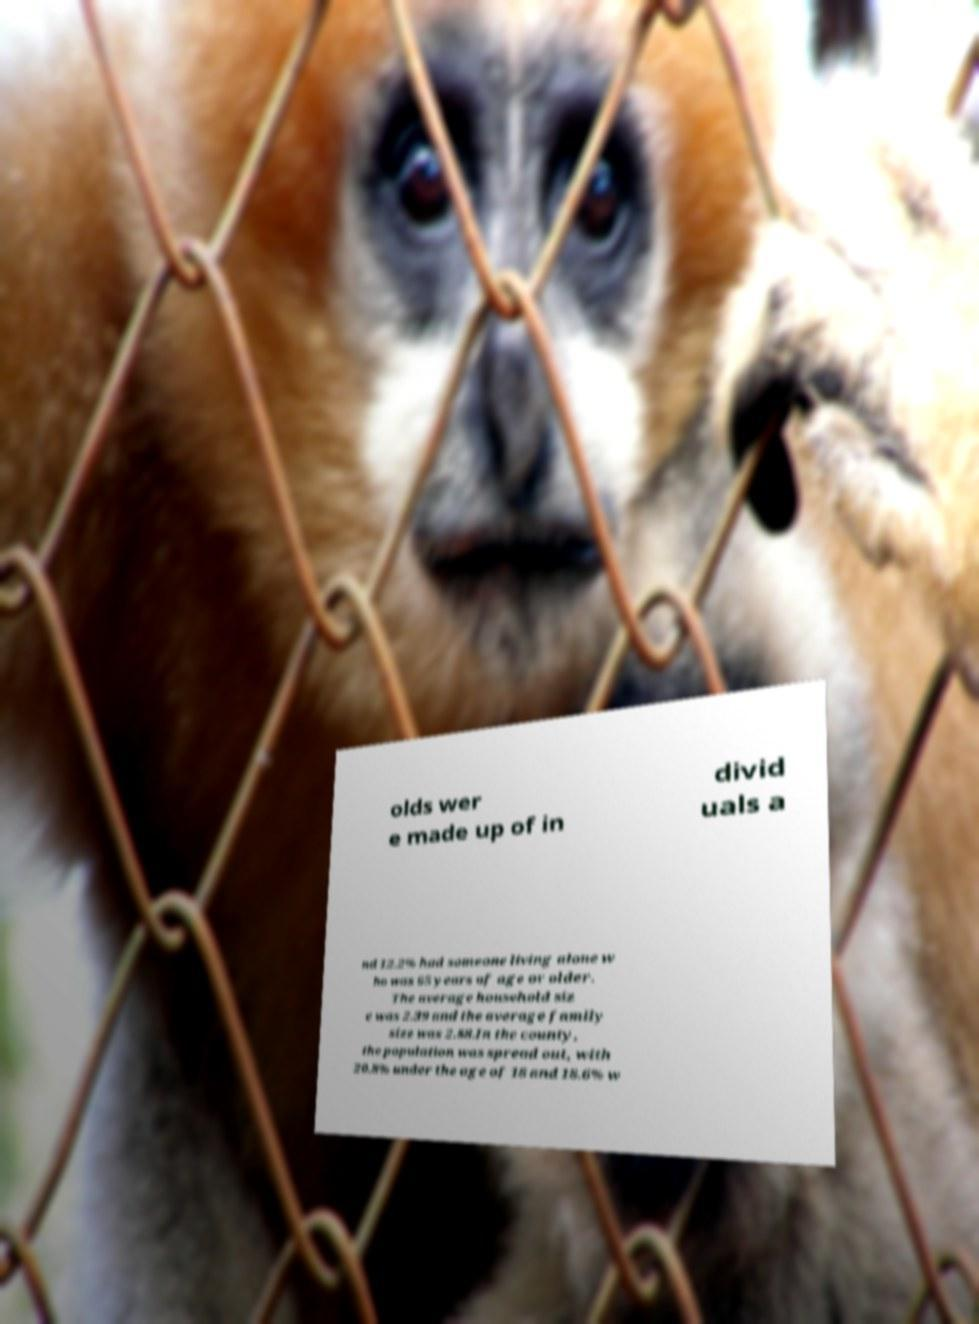Could you extract and type out the text from this image? olds wer e made up of in divid uals a nd 12.2% had someone living alone w ho was 65 years of age or older. The average household siz e was 2.39 and the average family size was 2.88.In the county, the population was spread out, with 20.8% under the age of 18 and 18.6% w 